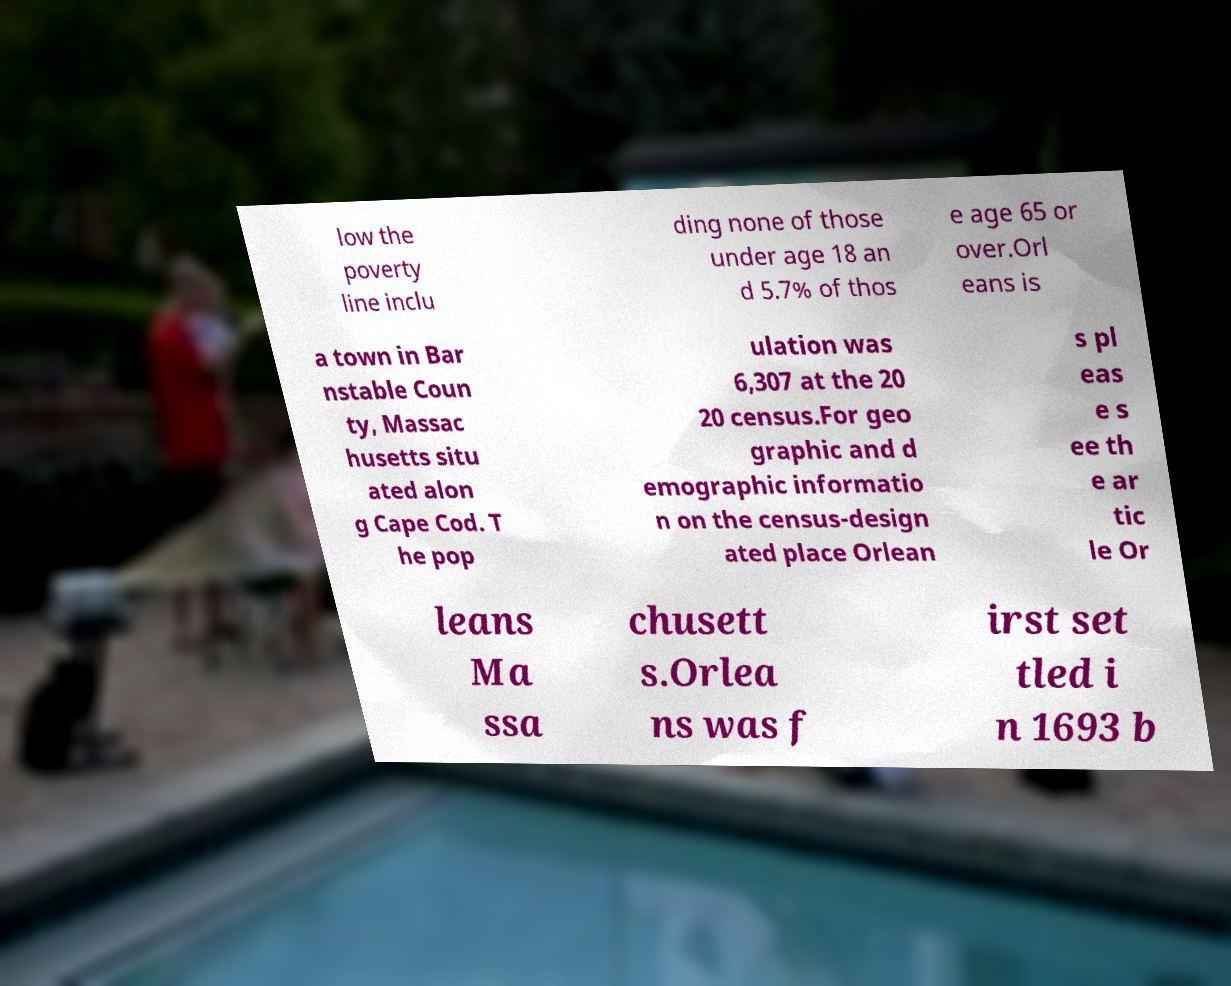What messages or text are displayed in this image? I need them in a readable, typed format. low the poverty line inclu ding none of those under age 18 an d 5.7% of thos e age 65 or over.Orl eans is a town in Bar nstable Coun ty, Massac husetts situ ated alon g Cape Cod. T he pop ulation was 6,307 at the 20 20 census.For geo graphic and d emographic informatio n on the census-design ated place Orlean s pl eas e s ee th e ar tic le Or leans Ma ssa chusett s.Orlea ns was f irst set tled i n 1693 b 